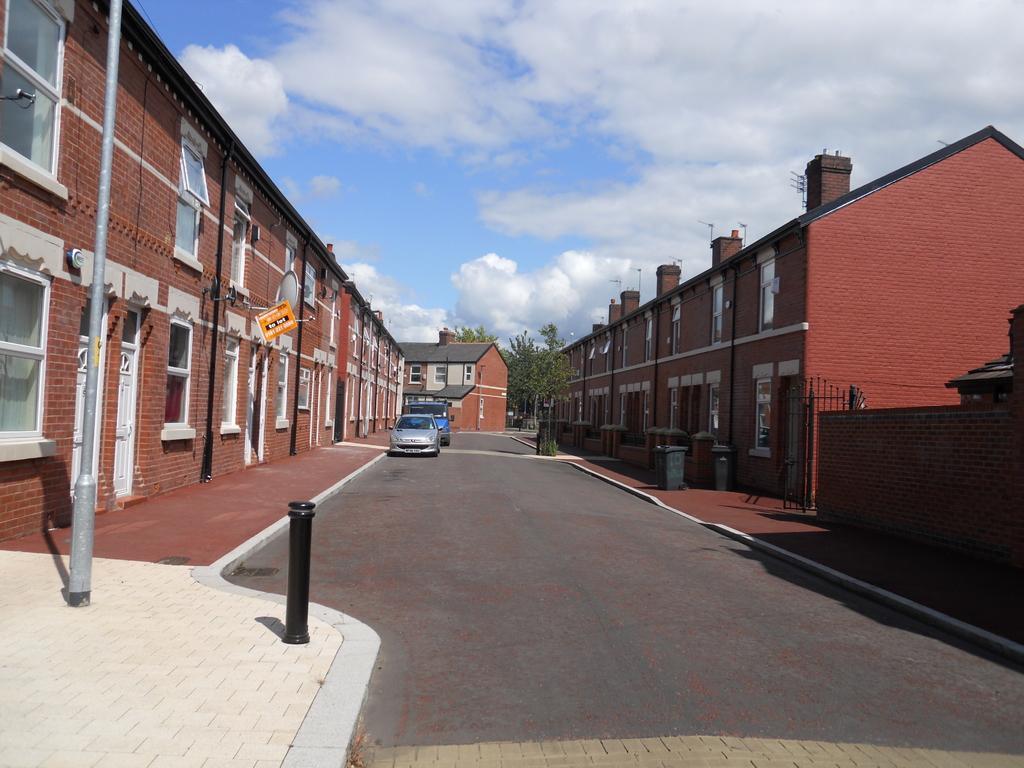Describe this image in one or two sentences. In this image I can see a road and few vehicles on it. I can also see few buildings, number of windows, few trees, few poles, an orange colour board and on it I can see something is written. In the background I can see clouds and the sky. 